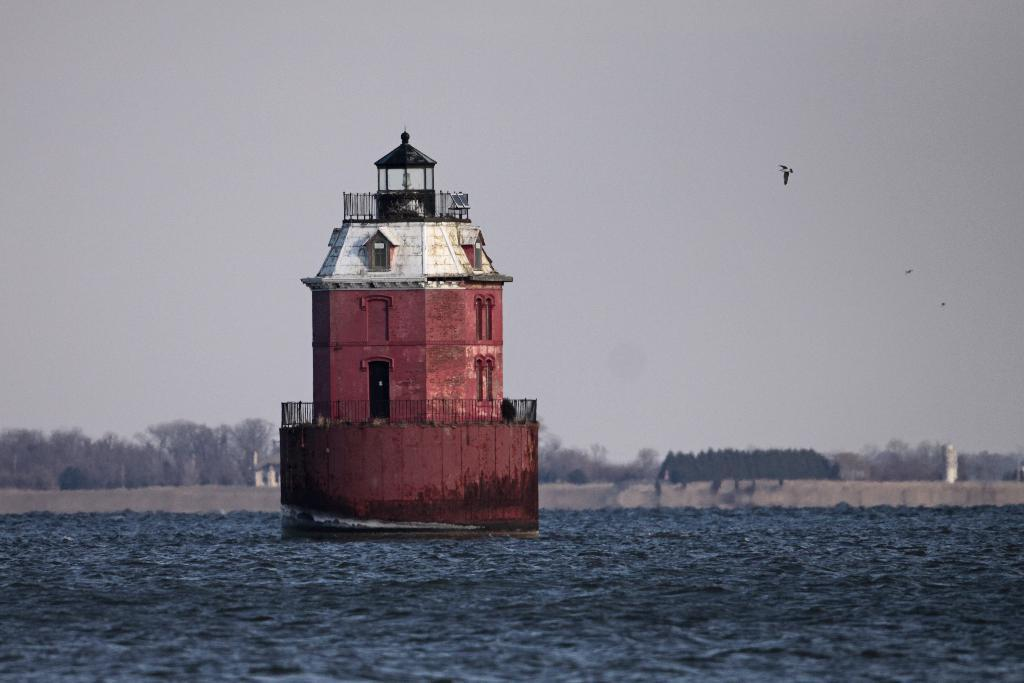What is at the bottom of the image? There is water at the bottom of the image. What structure can be seen in the image? There is a lighthouse in the image. What type of vegetation is visible in the background of the image? There are trees in the background of the image. What is visible at the top of the image? A: The sky is visible at the top of the image. How many hospitals are present in the image? There are no hospitals present in the image. What is the amount of protest visible in the image? There is no protest visible in the image; it features a lighthouse, water, trees, and the sky. 